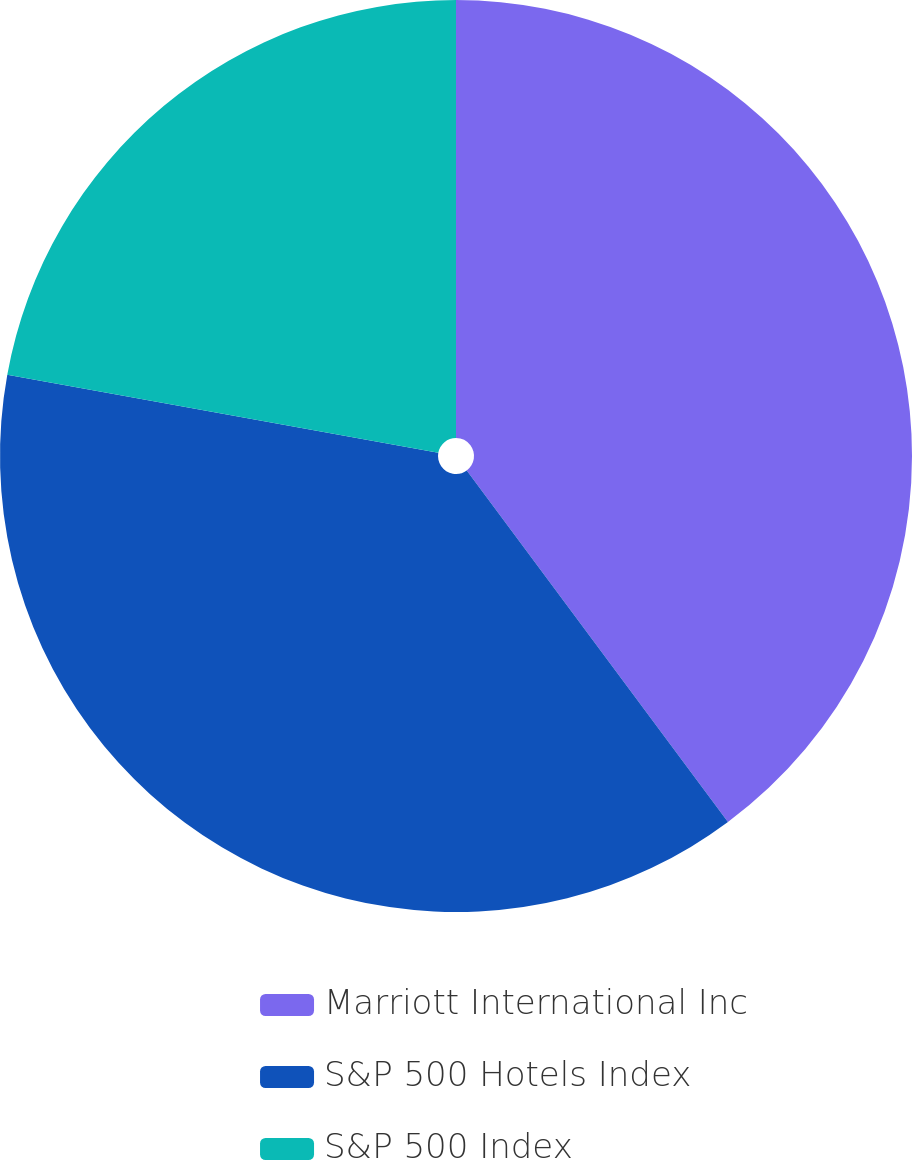Convert chart to OTSL. <chart><loc_0><loc_0><loc_500><loc_500><pie_chart><fcel>Marriott International Inc<fcel>S&P 500 Hotels Index<fcel>S&P 500 Index<nl><fcel>39.83%<fcel>38.02%<fcel>22.15%<nl></chart> 